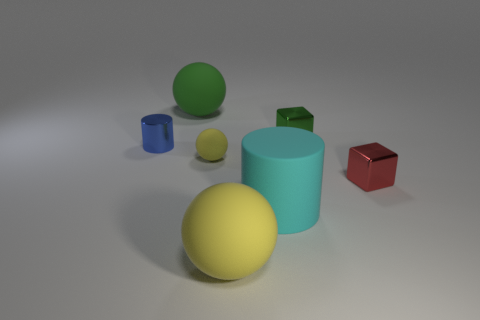Subtract all small yellow spheres. How many spheres are left? 2 Add 2 big gray shiny things. How many objects exist? 9 Subtract all cylinders. How many objects are left? 5 Subtract all yellow spheres. How many spheres are left? 1 Subtract 1 balls. How many balls are left? 2 Subtract all blue balls. How many blue cubes are left? 0 Subtract all tiny blue cylinders. Subtract all metallic things. How many objects are left? 3 Add 3 big green objects. How many big green objects are left? 4 Add 2 green rubber balls. How many green rubber balls exist? 3 Subtract 0 cyan blocks. How many objects are left? 7 